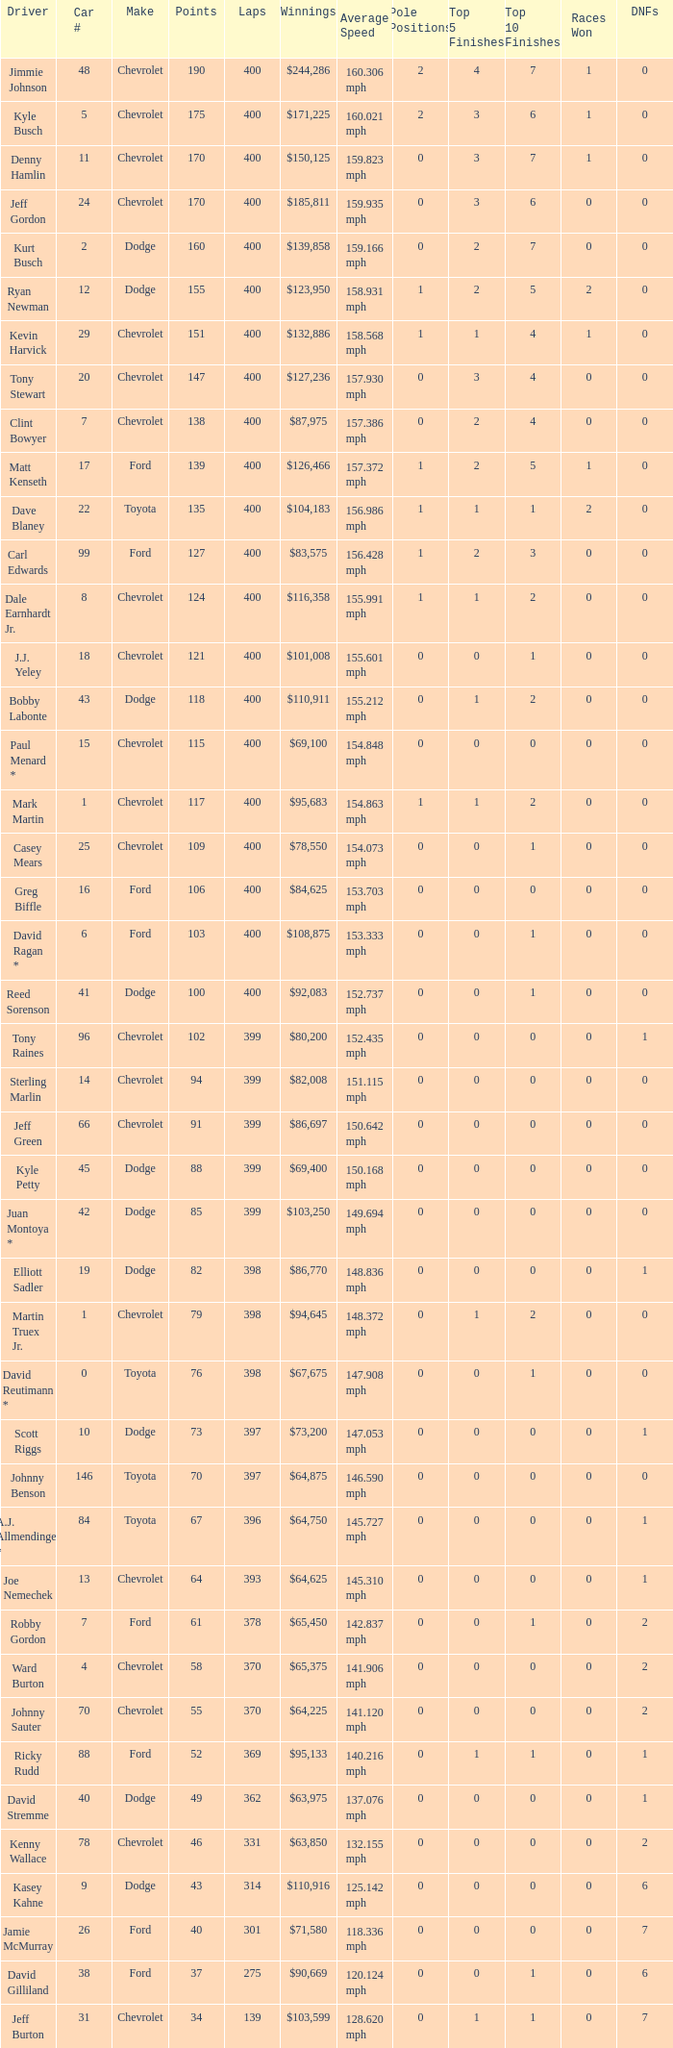What were the winnings for the Chevrolet with a number larger than 29 and scored 102 points? $80,200. 